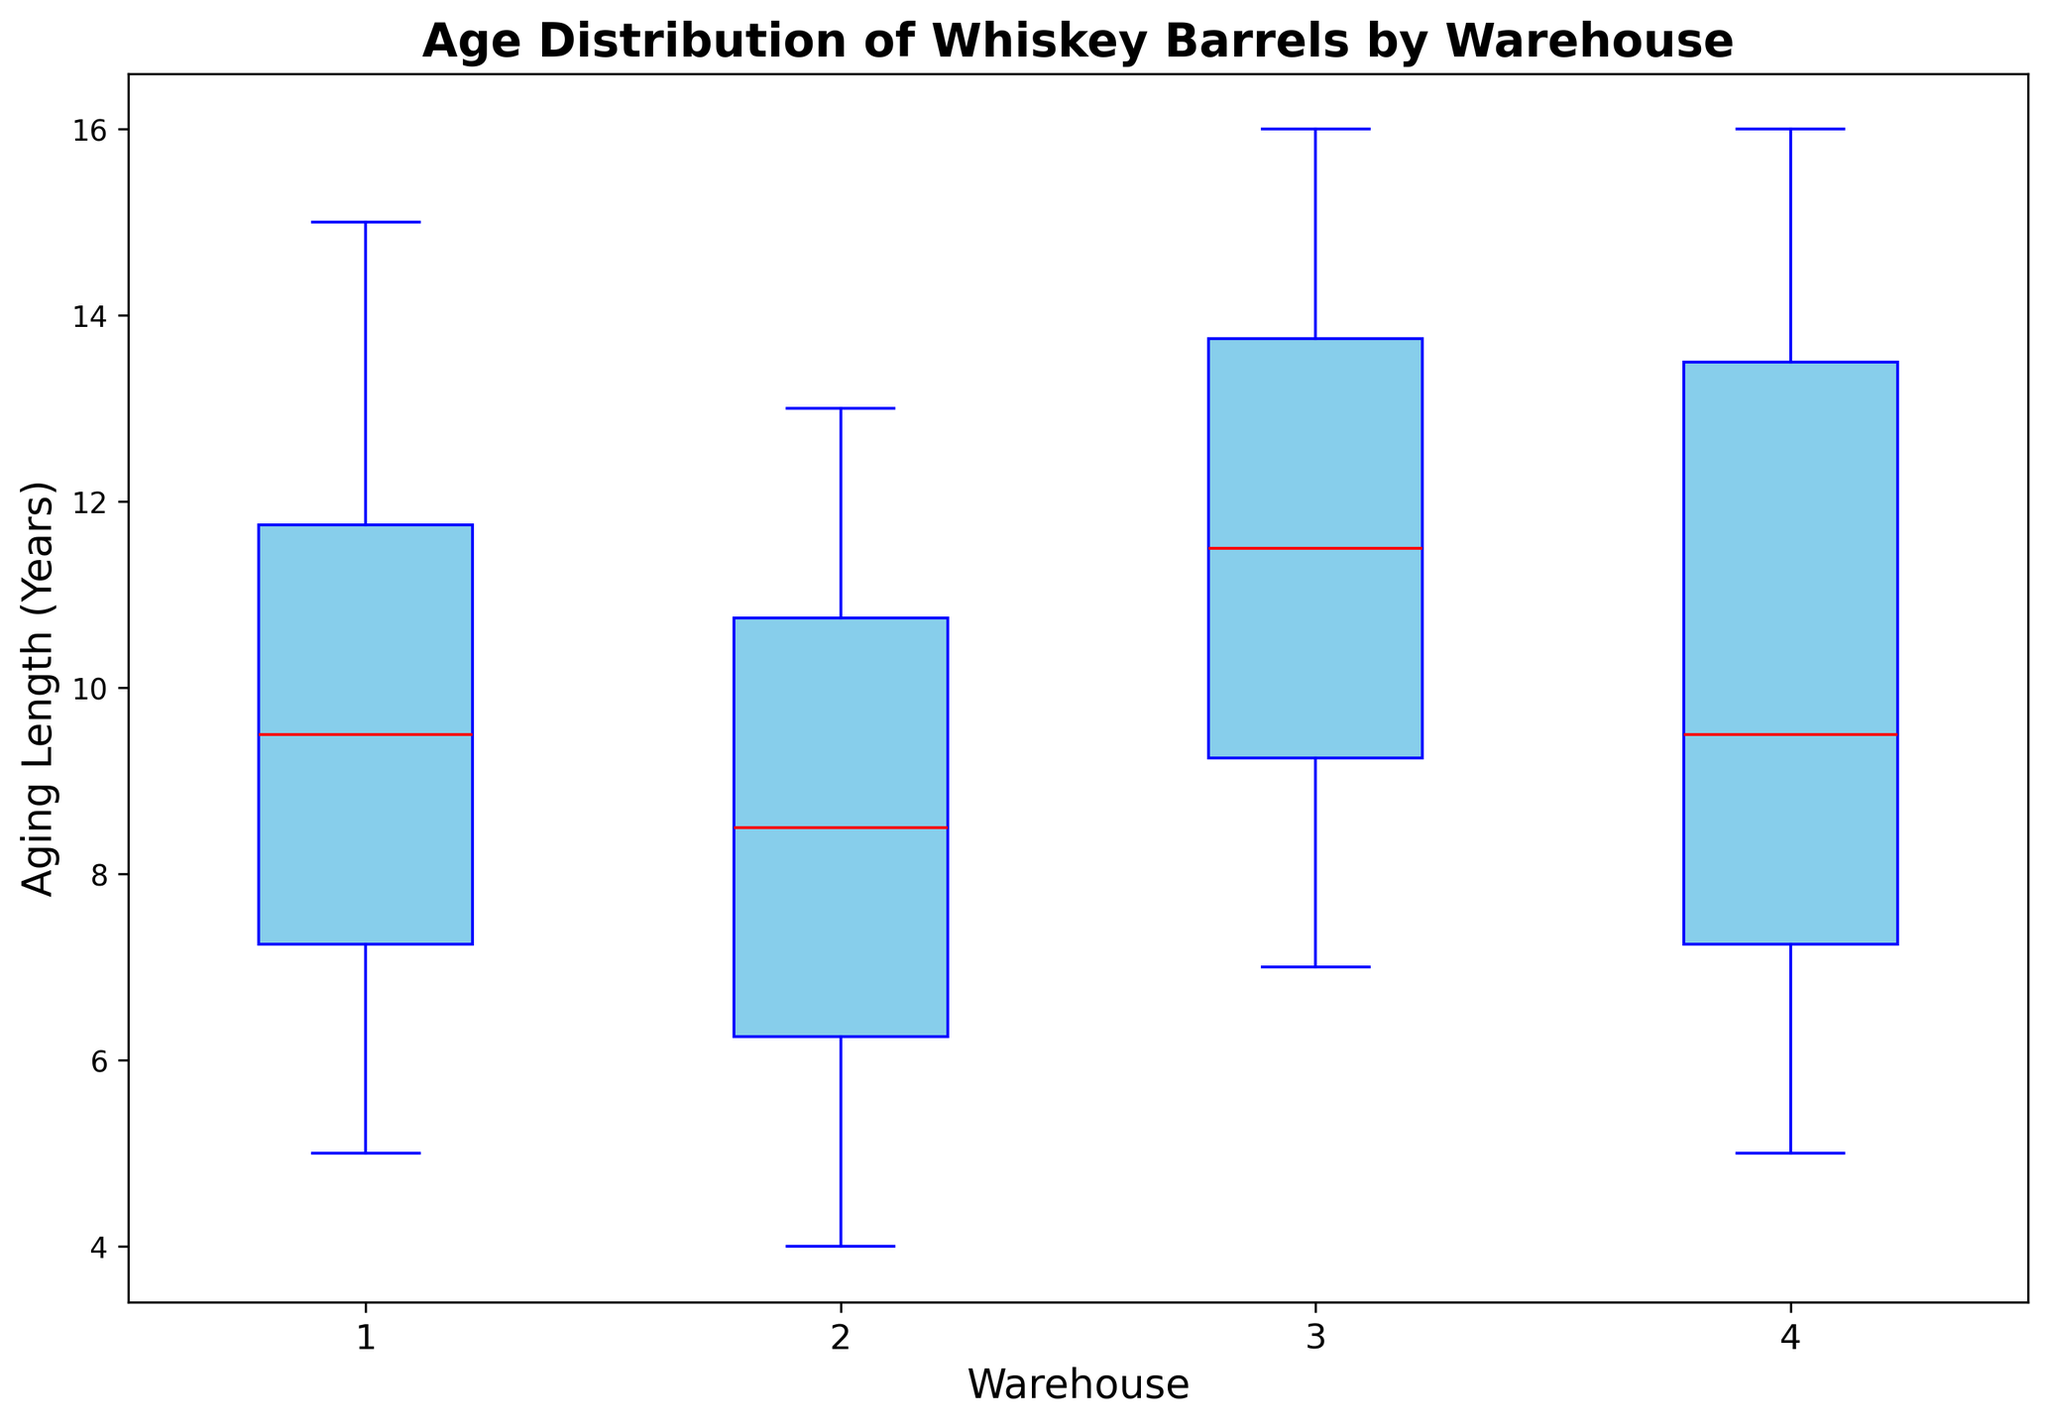What's the median age of whiskey barrels in Warehouse 1? To find the median age, locate the middle value when the ages are sorted. The sorted ages for Warehouse 1 are [5, 6, 7, 8, 9, 10, 11, 12, 14, 15]. The middle values are 9 and 10, the median is their average, (9+10)/2.
Answer: 9.5 How does the median age of whiskey barrels in Warehouse 3 compare to Warehouse 2? Determine the median ages of both. Warehouse 3 sorted ages: [7, 8, 9, 10, 11, 12, 13, 14, 15, 16], median is (11+12)/2 = 11.5. Warehouse 2 sorted ages: [4, 5, 6, 7, 8, 9, 10, 11, 12, 13], median is (8+9)/2 = 8.5. Compare 11.5 and 8.5.
Answer: Warehouse 3 has a higher median age Which warehouse has the oldest whiskey barrel? Identify the whiskers farthest to the right for maximum age. Whiskers provide the range, and the farthest right in the figure indicates Warehouse 4 and Warehouse 3. Thus, the oldest barrel is in these warehouses, both reaching 16 years.
Answer: Warehouse 4 and Warehouse 3 Which warehouse has the greatest range in whiskey barrel ages? Calculate or visually estimate the range by subtracting the minimum age (left whisker) from the maximum age (right whisker) for each warehouse. Warehouse 4's range: 16-5 = 11. Compare with other warehouses.
Answer: Warehouse 4 What is the interquartile range (IQR) of aging length in Warehouse 2? IQR is the difference between the third quartile (Q3) and the first quartile (Q1). For Warehouse 2, the sorted ages are [4, 5, 6, 7, 8, 9, 10, 11, 12, 13]. Q1 is 6, and Q3 is 11. IQR = 11-6.
Answer: 5 How many warehouses have a median aging length of 10 years or more? From the boxplot, identify warehouses with the red median line at 10 or above. Visual inspection shows that Warehouses 3 and 4 have medians of 10 or more.
Answer: 2 warehouses Which warehouse has the smallest interquartile range (IQR)? Identify the IQR for each warehouse (IQR = Q3 - Q1). Visual inspection suggests Warehouse 1, with the least vertical distance between Q1 and Q3.
Answer: Warehouse 1 